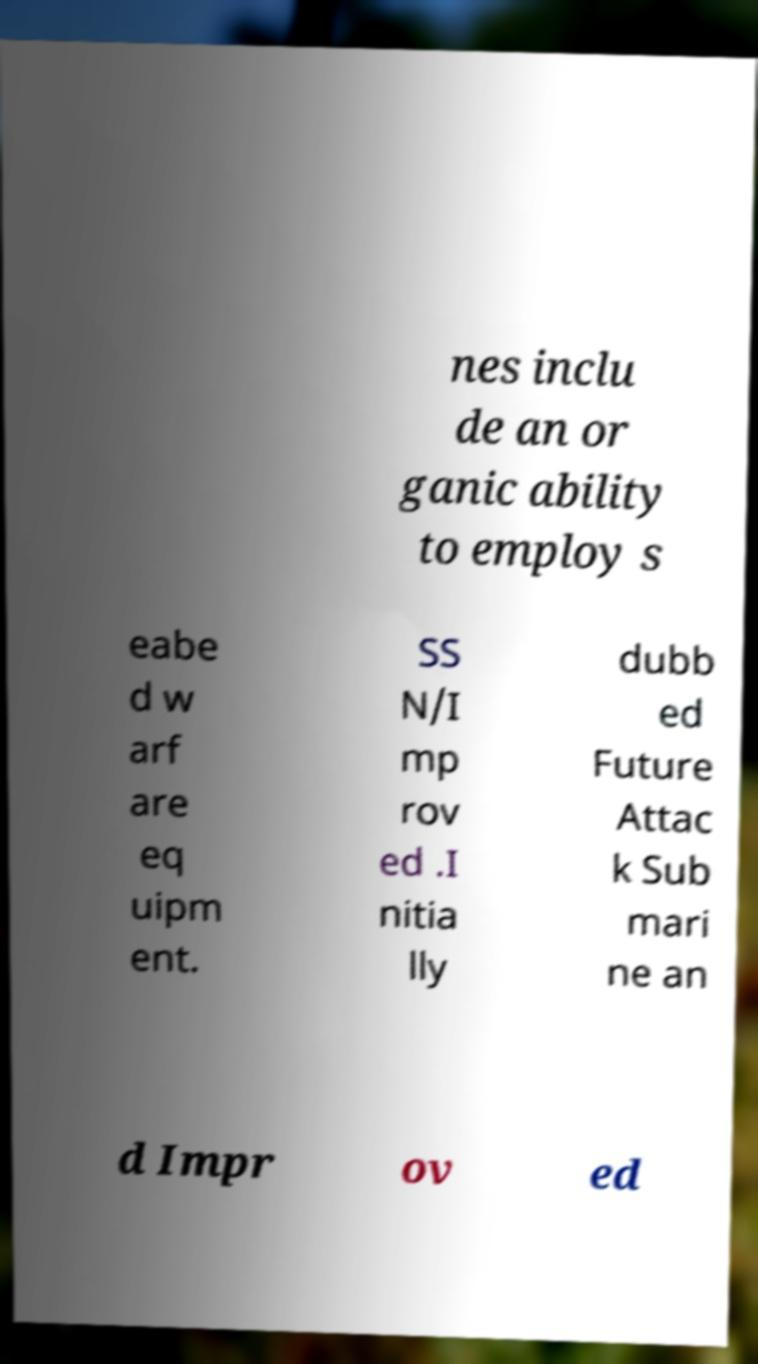Could you assist in decoding the text presented in this image and type it out clearly? nes inclu de an or ganic ability to employ s eabe d w arf are eq uipm ent. SS N/I mp rov ed .I nitia lly dubb ed Future Attac k Sub mari ne an d Impr ov ed 